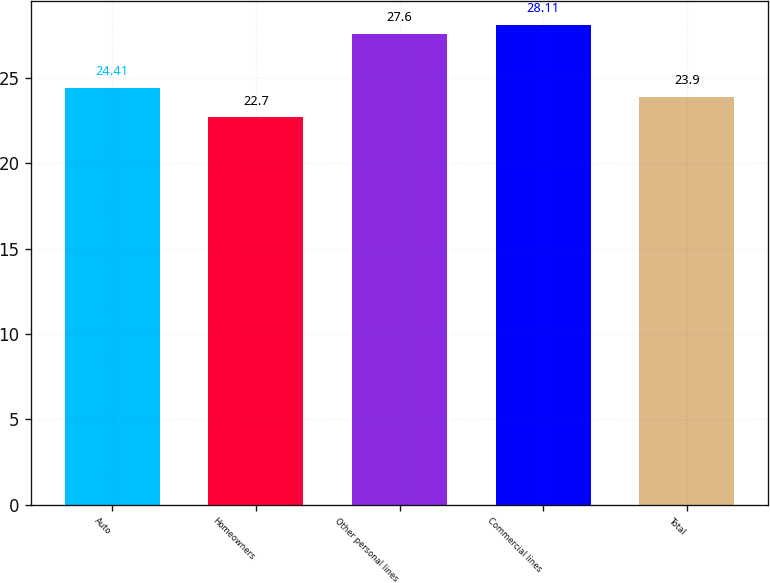<chart> <loc_0><loc_0><loc_500><loc_500><bar_chart><fcel>Auto<fcel>Homeowners<fcel>Other personal lines<fcel>Commercial lines<fcel>Total<nl><fcel>24.41<fcel>22.7<fcel>27.6<fcel>28.11<fcel>23.9<nl></chart> 